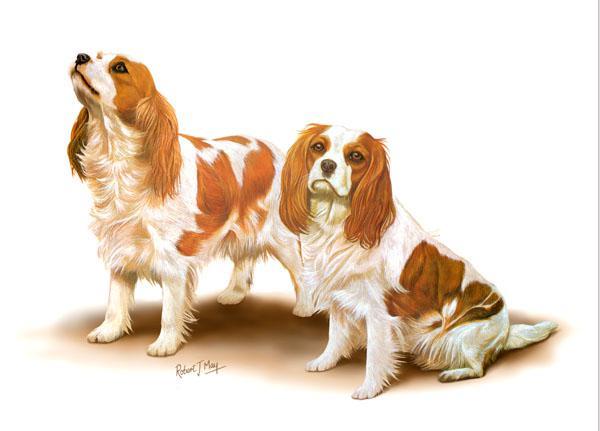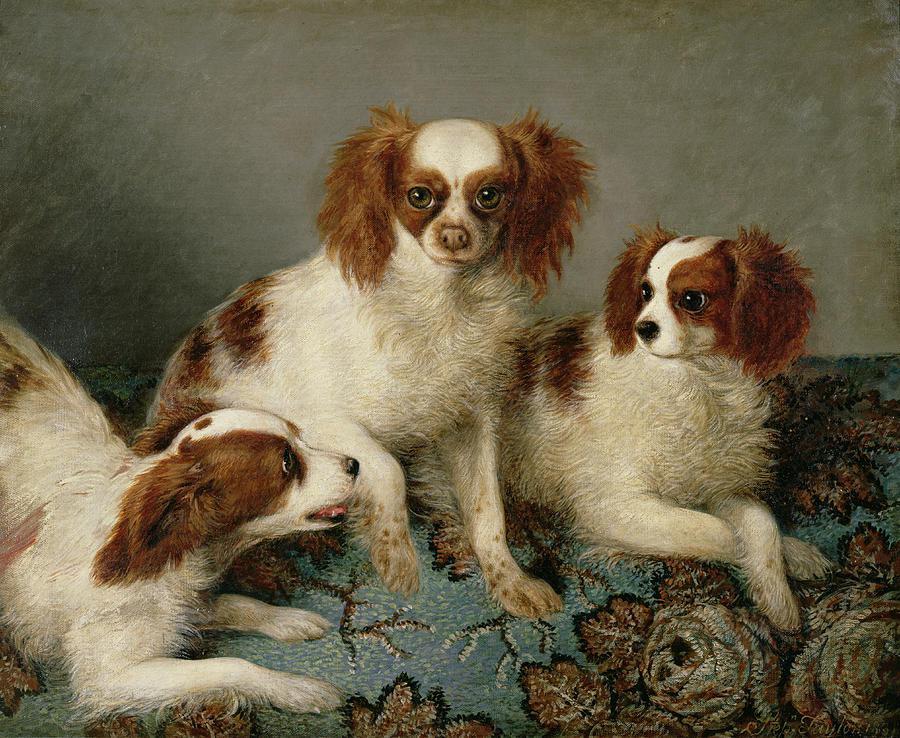The first image is the image on the left, the second image is the image on the right. Examine the images to the left and right. Is the description "Each image depicts a single spaniel dog, and the dogs on the right and left have different fur coloring." accurate? Answer yes or no. No. The first image is the image on the left, the second image is the image on the right. For the images shown, is this caption "There are 2 dogs." true? Answer yes or no. No. 